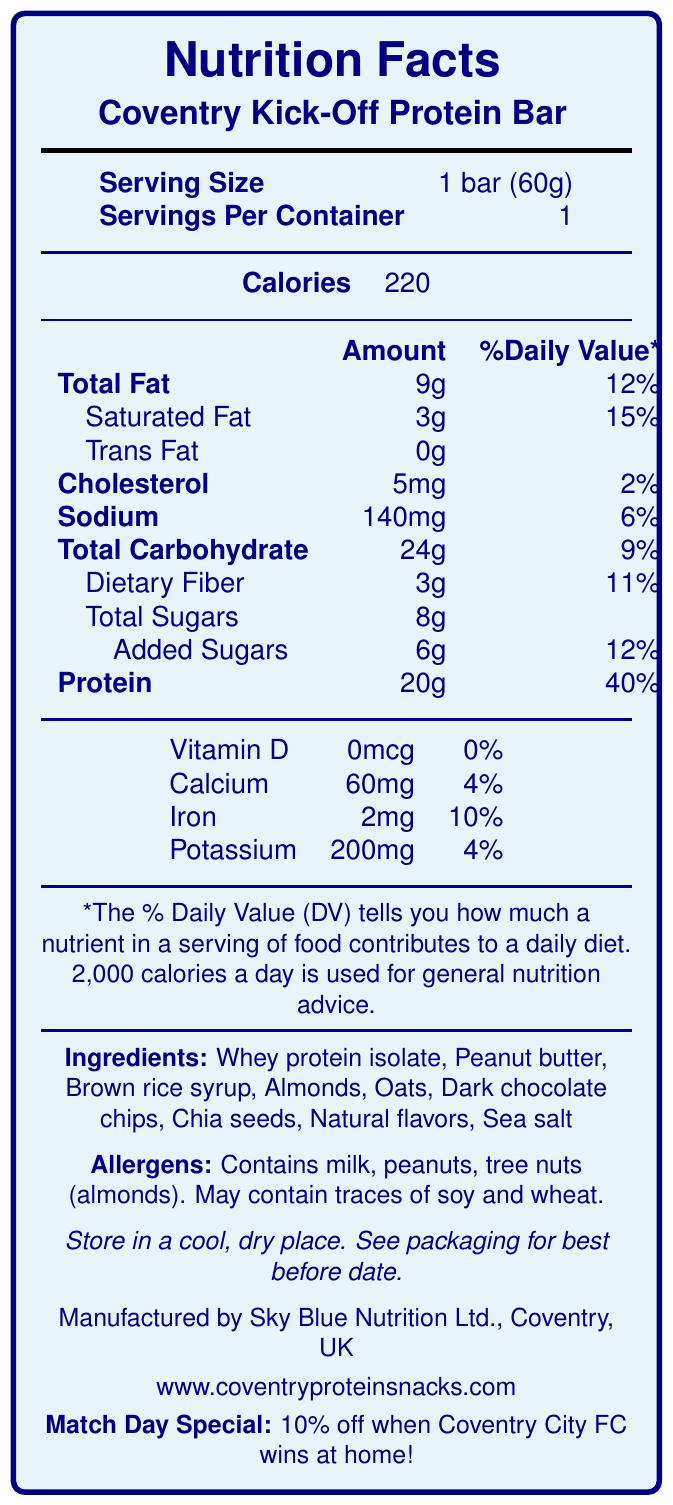What is the serving size of the Coventry Kick-Off Protein Bar? The serving size is clearly stated as "1 bar (60g)" in the nutrition facts.
Answer: 1 bar (60g) How many calories are there in one serving of Coventry Kick-Off Protein Bar? The document states that each serving, which is one bar, contains 220 calories.
Answer: 220 Which ingredient is listed first in the ingredients section? The ingredients are listed in order of quantity, and Whey Protein Isolate is listed first.
Answer: Whey protein isolate What is the percentage of Daily Value for protein in the Coventry Kick-Off Protein Bar? The document mentions that the protein content contributes 40% to the Daily Value.
Answer: 40% How much dietary fiber is in one bar? The document specifies that the bar contains 3g of dietary fiber.
Answer: 3g What is the total fat content in the Coventry Kick-Off Protein Bar? A. 5g B. 9g C. 15g D. 20g The nutrition facts label lists the total fat content as 9g.
Answer: B Which of the following allergens are contained in the Coventry Kick-Off Protein Bar? A. Soy B. Wheat C. Peanuts D. Eggs The allergen section mentions that the bar contains peanuts but may only contain traces of soy and wheat.
Answer: C What is the sodium content in the Coventry Kick-Off Protein Bar? The sodium content is listed as 140mg in the document.
Answer: 140mg Does the Coventry Kick-Off Protein Bar contain any trans fat? The document clearly states "Trans Fat 0g".
Answer: No Does the Coventry Kick-Off Protein Bar offer any discount related to Coventry City FC matches? The document mentions a "Match Day Special: 10% off when Coventry City FC wins at home".
Answer: Yes Summarize the main idea of the nutrition facts label for the Coventry Kick-Off Protein Bar. The document is a comprehensive label that details the nutritional information and ingredients of the Coventry Kick-Off Protein Bar, along with special promotional information.
Answer: The nutrition facts label provides detailed information about the nutrient content, including calories, fats, protein, vitamins, and minerals, as well as the list of ingredients, allergens, and additional product information. It also mentions a special discount offer related to Coventry City FC home game wins. Where is the best before date of the Coventry Kick-Off Protein Bar mentioned? The document instructs readers to "See packaging for best before date."
Answer: See packaging for details Who is the manufacturer of the Coventry Kick-Off Protein Bar? The manufacturer's information is listed as "Sky Blue Nutrition Ltd., Coventry, UK."
Answer: Sky Blue Nutrition Ltd., Coventry, UK How much Calcium does the Coventry Kick-Off Protein Bar contain? The document states that there is 60mg of Calcium per bar.
Answer: 60mg Are there any traces of wheat in the Coventry Kick-Off Protein Bar? A. Yes B. No C. Not mentioned The allergen information section specifies that the bar "may contain traces of soy and wheat."
Answer: A What is the website for more information about Coventry Kick-Off Protein Bar? The website is mentioned at the bottom of the document for additional information.
Answer: www.coventryproteinsnacks.com What are the natural flavors used in the Coventry Kick-Off Protein Bar? The document lists "Natural flavors" but does not specify what they are exactly.
Answer: Not enough information 